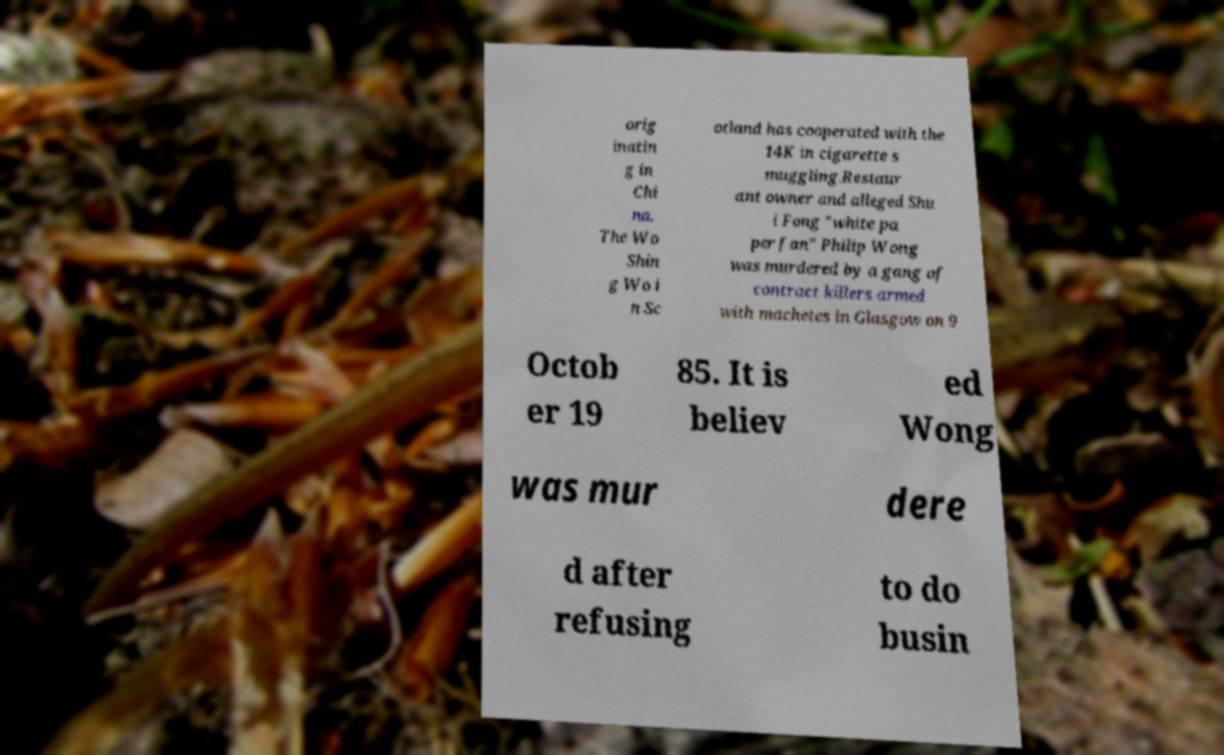Please identify and transcribe the text found in this image. orig inatin g in Chi na. The Wo Shin g Wo i n Sc otland has cooperated with the 14K in cigarette s muggling.Restaur ant owner and alleged Shu i Fong "white pa per fan" Philip Wong was murdered by a gang of contract killers armed with machetes in Glasgow on 9 Octob er 19 85. It is believ ed Wong was mur dere d after refusing to do busin 